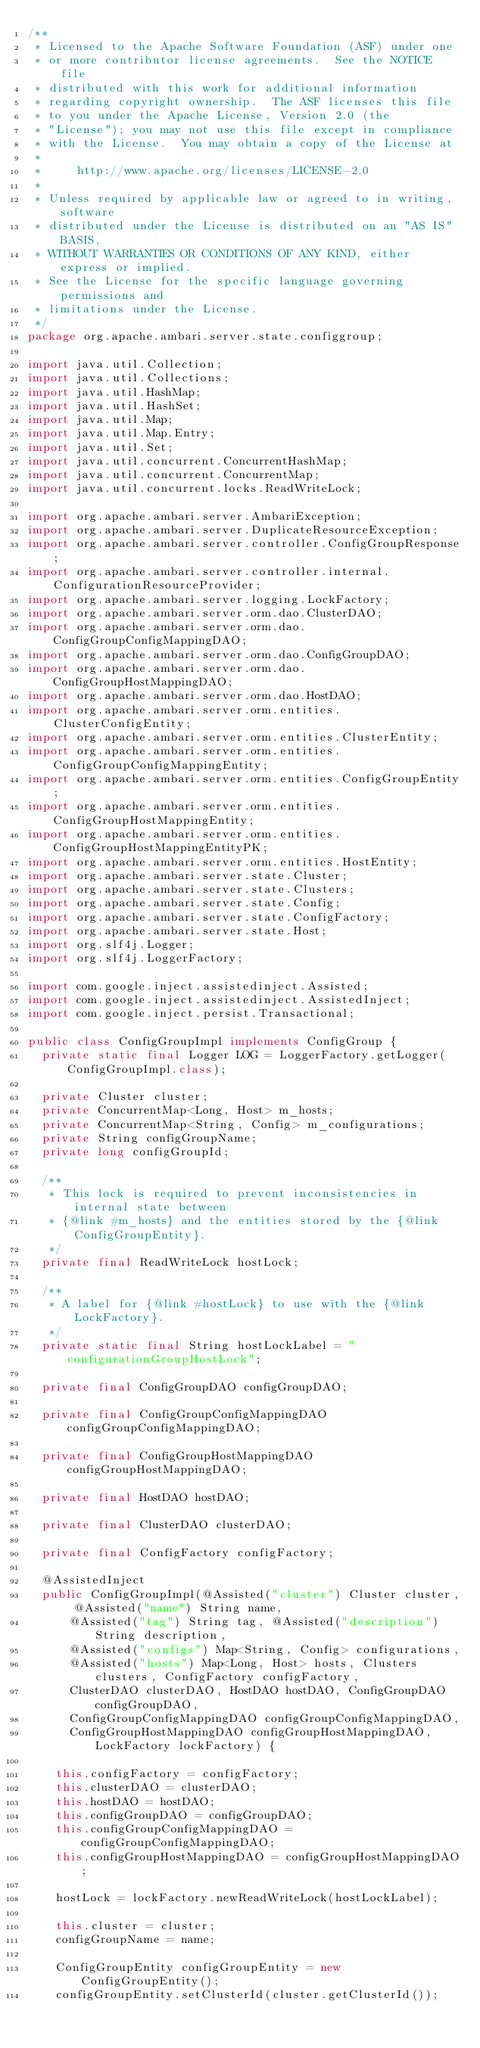<code> <loc_0><loc_0><loc_500><loc_500><_Java_>/**
 * Licensed to the Apache Software Foundation (ASF) under one
 * or more contributor license agreements.  See the NOTICE file
 * distributed with this work for additional information
 * regarding copyright ownership.  The ASF licenses this file
 * to you under the Apache License, Version 2.0 (the
 * "License"); you may not use this file except in compliance
 * with the License.  You may obtain a copy of the License at
 *
 *     http://www.apache.org/licenses/LICENSE-2.0
 *
 * Unless required by applicable law or agreed to in writing, software
 * distributed under the License is distributed on an "AS IS" BASIS,
 * WITHOUT WARRANTIES OR CONDITIONS OF ANY KIND, either express or implied.
 * See the License for the specific language governing permissions and
 * limitations under the License.
 */
package org.apache.ambari.server.state.configgroup;

import java.util.Collection;
import java.util.Collections;
import java.util.HashMap;
import java.util.HashSet;
import java.util.Map;
import java.util.Map.Entry;
import java.util.Set;
import java.util.concurrent.ConcurrentHashMap;
import java.util.concurrent.ConcurrentMap;
import java.util.concurrent.locks.ReadWriteLock;

import org.apache.ambari.server.AmbariException;
import org.apache.ambari.server.DuplicateResourceException;
import org.apache.ambari.server.controller.ConfigGroupResponse;
import org.apache.ambari.server.controller.internal.ConfigurationResourceProvider;
import org.apache.ambari.server.logging.LockFactory;
import org.apache.ambari.server.orm.dao.ClusterDAO;
import org.apache.ambari.server.orm.dao.ConfigGroupConfigMappingDAO;
import org.apache.ambari.server.orm.dao.ConfigGroupDAO;
import org.apache.ambari.server.orm.dao.ConfigGroupHostMappingDAO;
import org.apache.ambari.server.orm.dao.HostDAO;
import org.apache.ambari.server.orm.entities.ClusterConfigEntity;
import org.apache.ambari.server.orm.entities.ClusterEntity;
import org.apache.ambari.server.orm.entities.ConfigGroupConfigMappingEntity;
import org.apache.ambari.server.orm.entities.ConfigGroupEntity;
import org.apache.ambari.server.orm.entities.ConfigGroupHostMappingEntity;
import org.apache.ambari.server.orm.entities.ConfigGroupHostMappingEntityPK;
import org.apache.ambari.server.orm.entities.HostEntity;
import org.apache.ambari.server.state.Cluster;
import org.apache.ambari.server.state.Clusters;
import org.apache.ambari.server.state.Config;
import org.apache.ambari.server.state.ConfigFactory;
import org.apache.ambari.server.state.Host;
import org.slf4j.Logger;
import org.slf4j.LoggerFactory;

import com.google.inject.assistedinject.Assisted;
import com.google.inject.assistedinject.AssistedInject;
import com.google.inject.persist.Transactional;

public class ConfigGroupImpl implements ConfigGroup {
  private static final Logger LOG = LoggerFactory.getLogger(ConfigGroupImpl.class);

  private Cluster cluster;
  private ConcurrentMap<Long, Host> m_hosts;
  private ConcurrentMap<String, Config> m_configurations;
  private String configGroupName;
  private long configGroupId;

  /**
   * This lock is required to prevent inconsistencies in internal state between
   * {@link #m_hosts} and the entities stored by the {@link ConfigGroupEntity}.
   */
  private final ReadWriteLock hostLock;

  /**
   * A label for {@link #hostLock} to use with the {@link LockFactory}.
   */
  private static final String hostLockLabel = "configurationGroupHostLock";

  private final ConfigGroupDAO configGroupDAO;

  private final ConfigGroupConfigMappingDAO configGroupConfigMappingDAO;

  private final ConfigGroupHostMappingDAO configGroupHostMappingDAO;

  private final HostDAO hostDAO;

  private final ClusterDAO clusterDAO;

  private final ConfigFactory configFactory;

  @AssistedInject
  public ConfigGroupImpl(@Assisted("cluster") Cluster cluster, @Assisted("name") String name,
      @Assisted("tag") String tag, @Assisted("description") String description,
      @Assisted("configs") Map<String, Config> configurations,
      @Assisted("hosts") Map<Long, Host> hosts, Clusters clusters, ConfigFactory configFactory,
      ClusterDAO clusterDAO, HostDAO hostDAO, ConfigGroupDAO configGroupDAO,
      ConfigGroupConfigMappingDAO configGroupConfigMappingDAO,
      ConfigGroupHostMappingDAO configGroupHostMappingDAO, LockFactory lockFactory) {

    this.configFactory = configFactory;
    this.clusterDAO = clusterDAO;
    this.hostDAO = hostDAO;
    this.configGroupDAO = configGroupDAO;
    this.configGroupConfigMappingDAO = configGroupConfigMappingDAO;
    this.configGroupHostMappingDAO = configGroupHostMappingDAO;

    hostLock = lockFactory.newReadWriteLock(hostLockLabel);

    this.cluster = cluster;
    configGroupName = name;

    ConfigGroupEntity configGroupEntity = new ConfigGroupEntity();
    configGroupEntity.setClusterId(cluster.getClusterId());</code> 